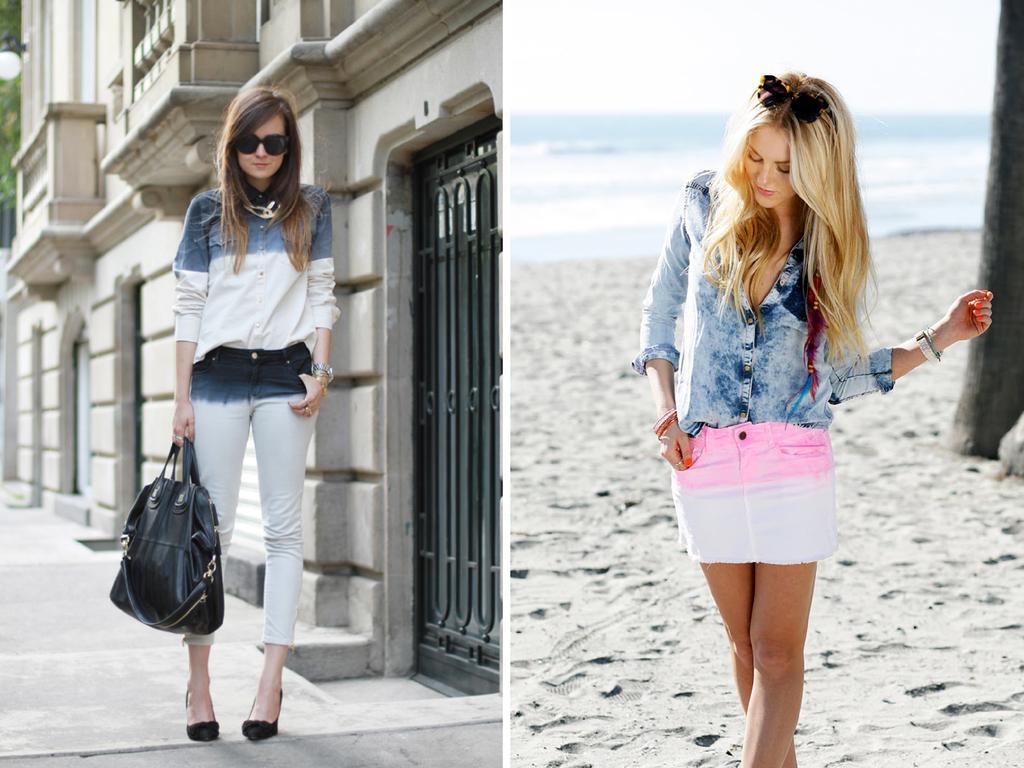Describe this image in one or two sentences. This is a collage image and we can see the both woman in this image giving poses and the woman in the left is having a handbag in her hand and she is wearing goggles 